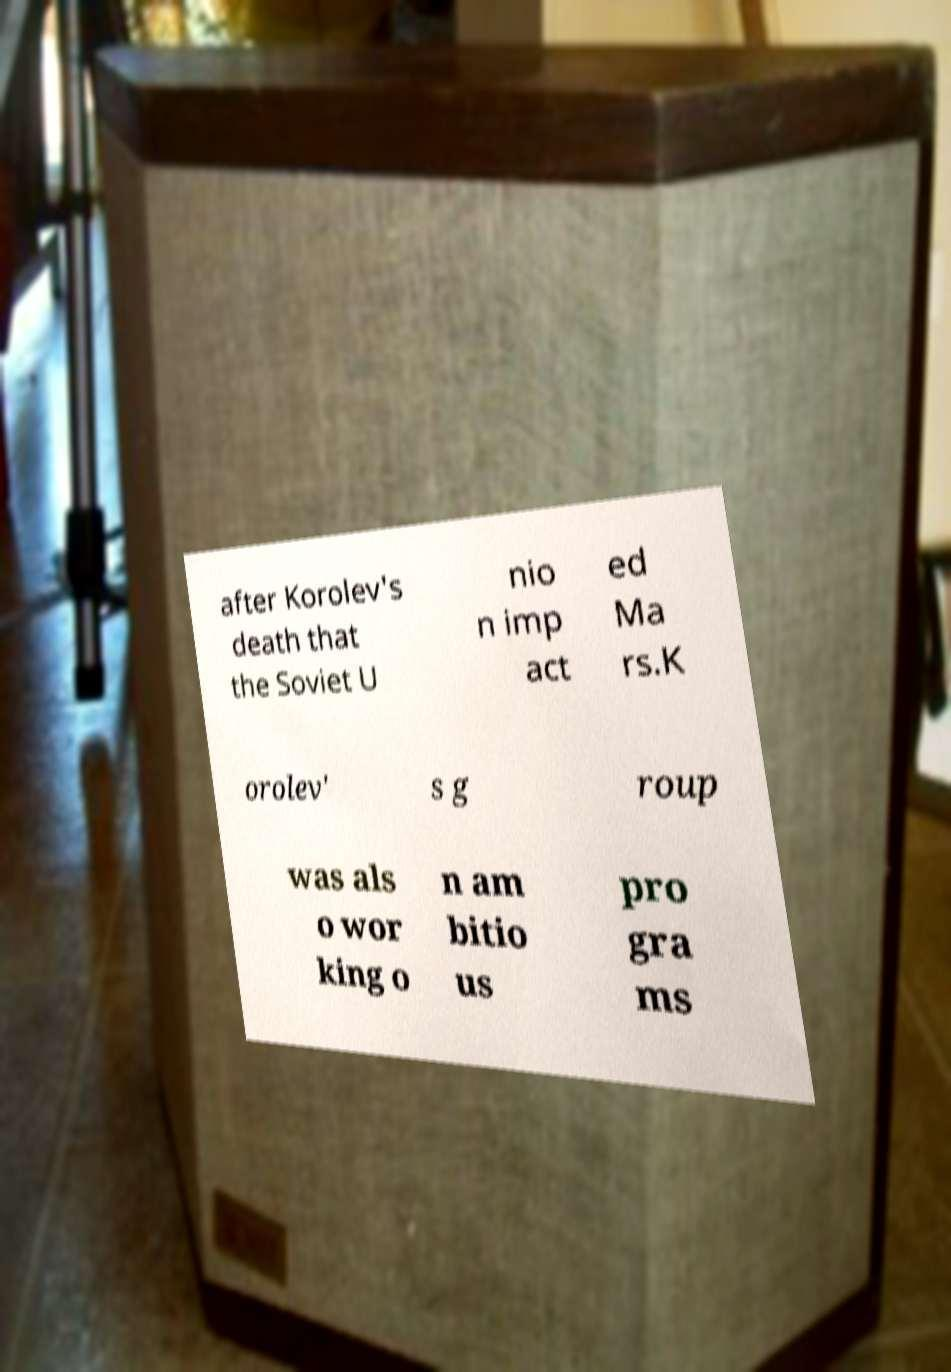For documentation purposes, I need the text within this image transcribed. Could you provide that? after Korolev's death that the Soviet U nio n imp act ed Ma rs.K orolev' s g roup was als o wor king o n am bitio us pro gra ms 